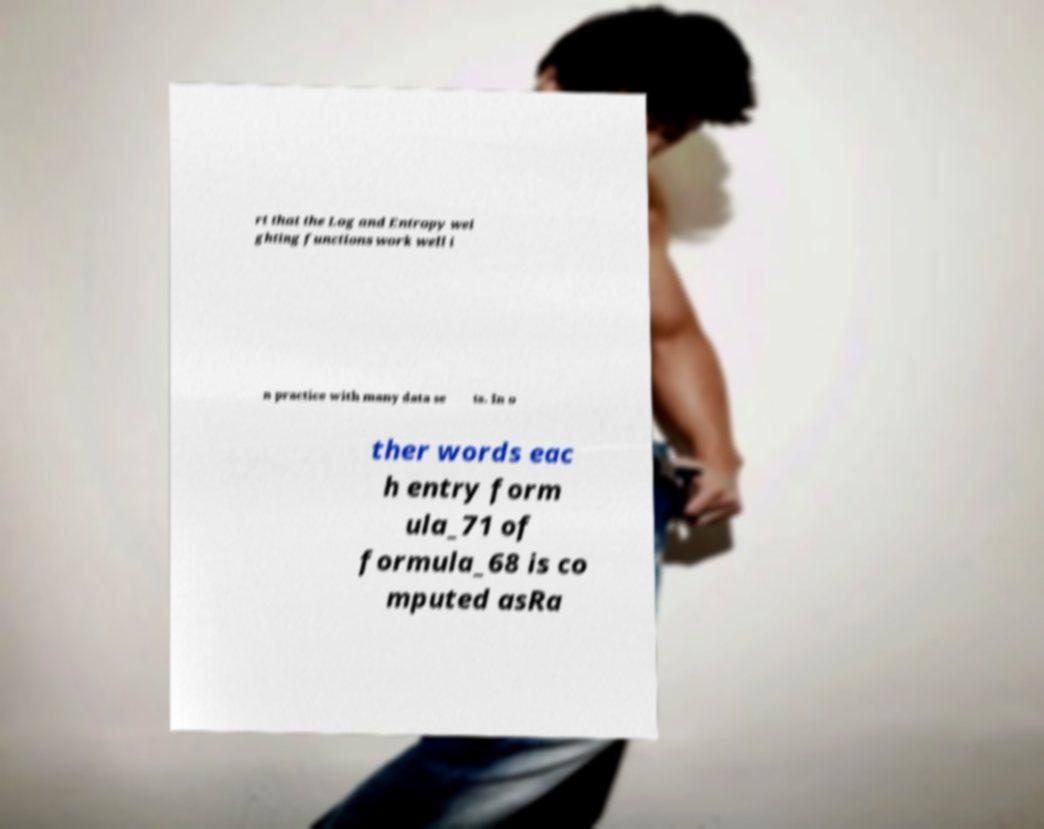Could you extract and type out the text from this image? rt that the Log and Entropy wei ghting functions work well i n practice with many data se ts. In o ther words eac h entry form ula_71 of formula_68 is co mputed asRa 